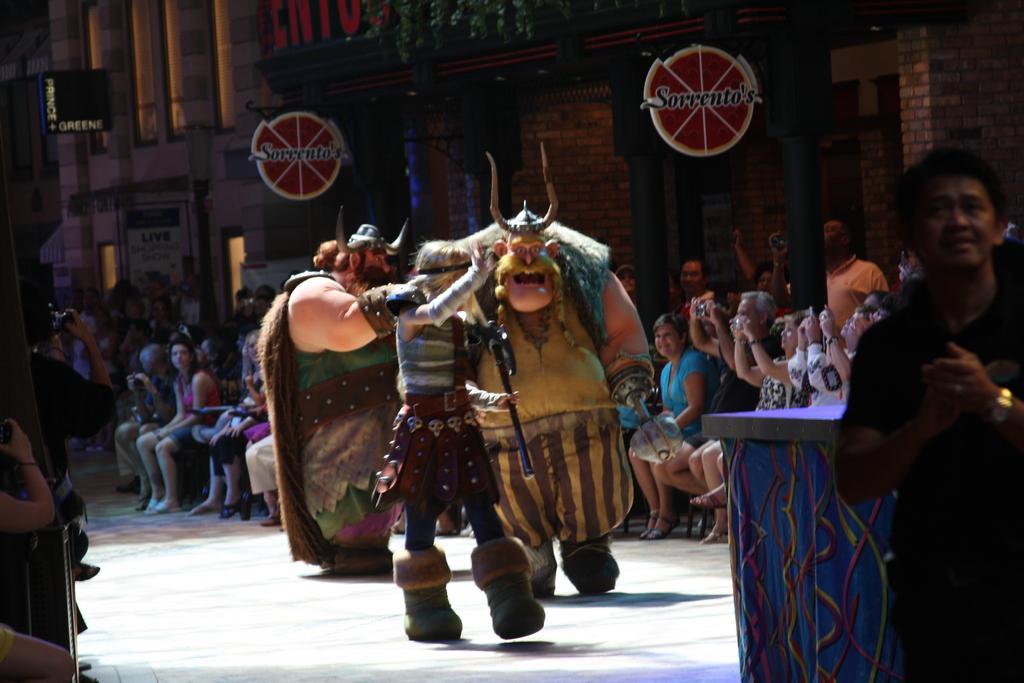Please provide a concise description of this image. In the image there are three persons walking on the ramp in ancient costumes, there are people on either sides sitting and clicking pictures in the camera and behind there is a wall. 